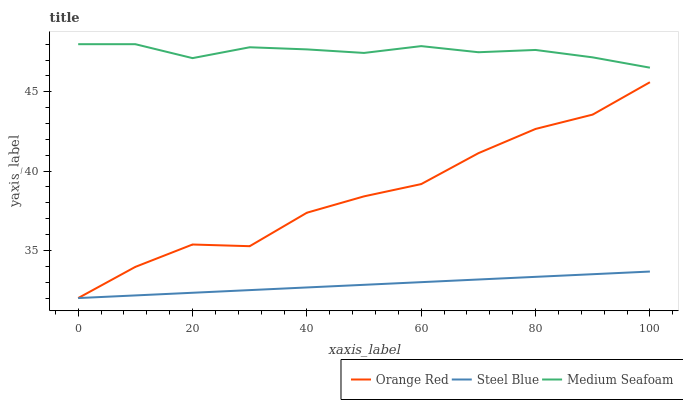Does Steel Blue have the minimum area under the curve?
Answer yes or no. Yes. Does Medium Seafoam have the maximum area under the curve?
Answer yes or no. Yes. Does Orange Red have the minimum area under the curve?
Answer yes or no. No. Does Orange Red have the maximum area under the curve?
Answer yes or no. No. Is Steel Blue the smoothest?
Answer yes or no. Yes. Is Orange Red the roughest?
Answer yes or no. Yes. Is Orange Red the smoothest?
Answer yes or no. No. Is Steel Blue the roughest?
Answer yes or no. No. Does Medium Seafoam have the highest value?
Answer yes or no. Yes. Does Orange Red have the highest value?
Answer yes or no. No. Is Orange Red less than Medium Seafoam?
Answer yes or no. Yes. Is Medium Seafoam greater than Orange Red?
Answer yes or no. Yes. Does Orange Red intersect Steel Blue?
Answer yes or no. Yes. Is Orange Red less than Steel Blue?
Answer yes or no. No. Is Orange Red greater than Steel Blue?
Answer yes or no. No. Does Orange Red intersect Medium Seafoam?
Answer yes or no. No. 